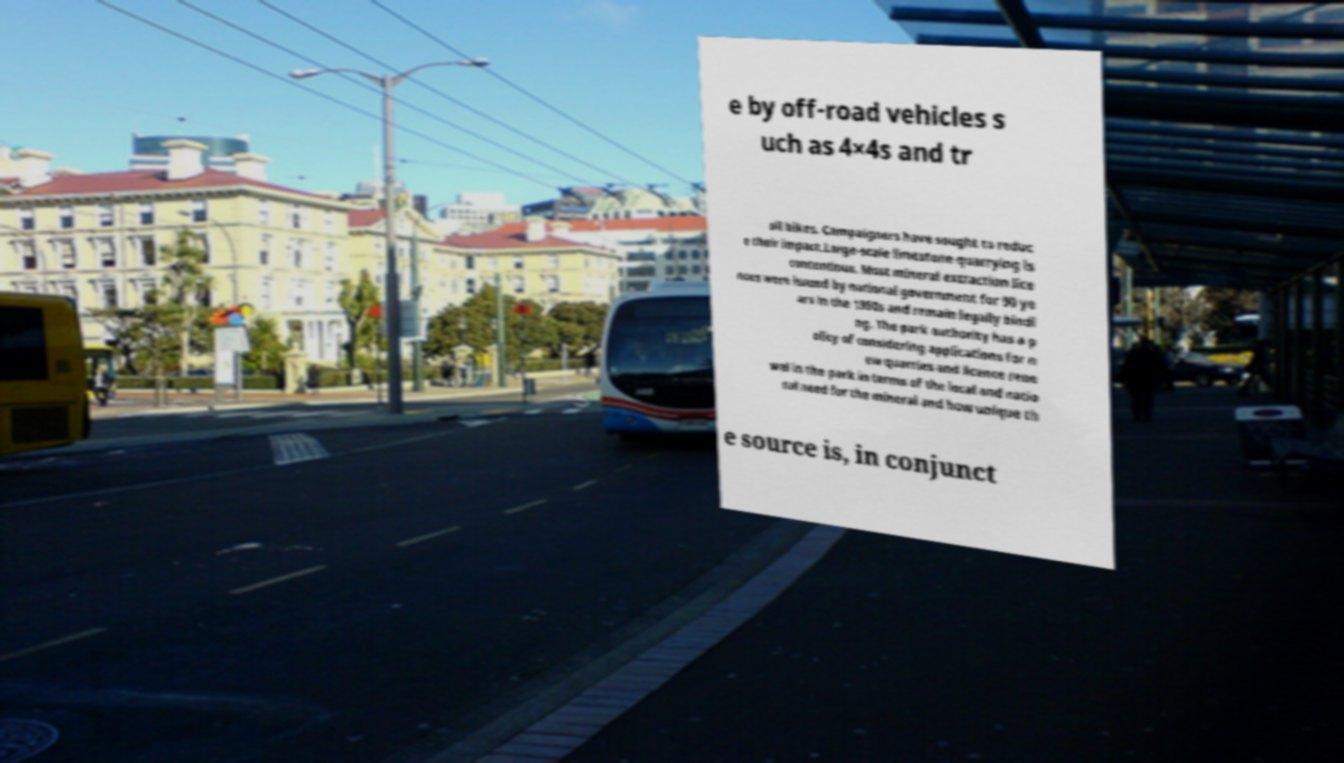For documentation purposes, I need the text within this image transcribed. Could you provide that? e by off-road vehicles s uch as 4×4s and tr ail bikes. Campaigners have sought to reduc e their impact.Large-scale limestone quarrying is contentious. Most mineral extraction lice nces were issued by national government for 90 ye ars in the 1950s and remain legally bindi ng. The park authority has a p olicy of considering applications for n ew quarries and licence rene wal in the park in terms of the local and natio nal need for the mineral and how unique th e source is, in conjunct 